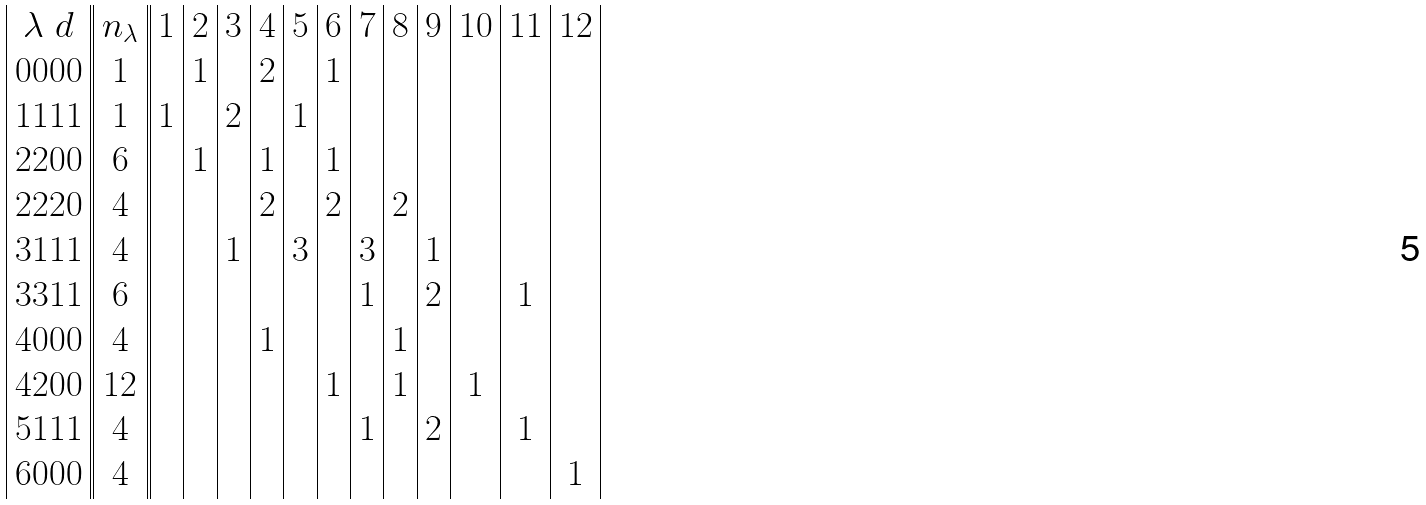<formula> <loc_0><loc_0><loc_500><loc_500>\begin{array} { | c | | c | | c | c | c | c | c | c | c | c | c | c | c | c | } \lambda \ d & n _ { \lambda } & 1 & 2 & 3 & 4 & 5 & 6 & 7 & 8 & 9 & 1 0 & 1 1 & 1 2 \\ 0 0 0 0 & 1 & & 1 & & 2 & & 1 & & & & & & \\ 1 1 1 1 & 1 & 1 & & 2 & & 1 & & & & & & & \\ 2 2 0 0 & 6 & & 1 & & 1 & & 1 & & & & & & \\ 2 2 2 0 & 4 & & & & 2 & & 2 & & 2 & & & & \\ 3 1 1 1 & 4 & & & 1 & & 3 & & 3 & & 1 & & & \\ 3 3 1 1 & 6 & & & & & & & 1 & & 2 & & 1 & \\ 4 0 0 0 & 4 & & & & 1 & & & & 1 & & & & \\ 4 2 0 0 & 1 2 & & & & & & 1 & & 1 & & 1 & & \\ 5 1 1 1 & 4 & & & & & & & 1 & & 2 & & 1 & \\ 6 0 0 0 & 4 & & & & & & & & & & & & 1 \\ \end{array}</formula> 